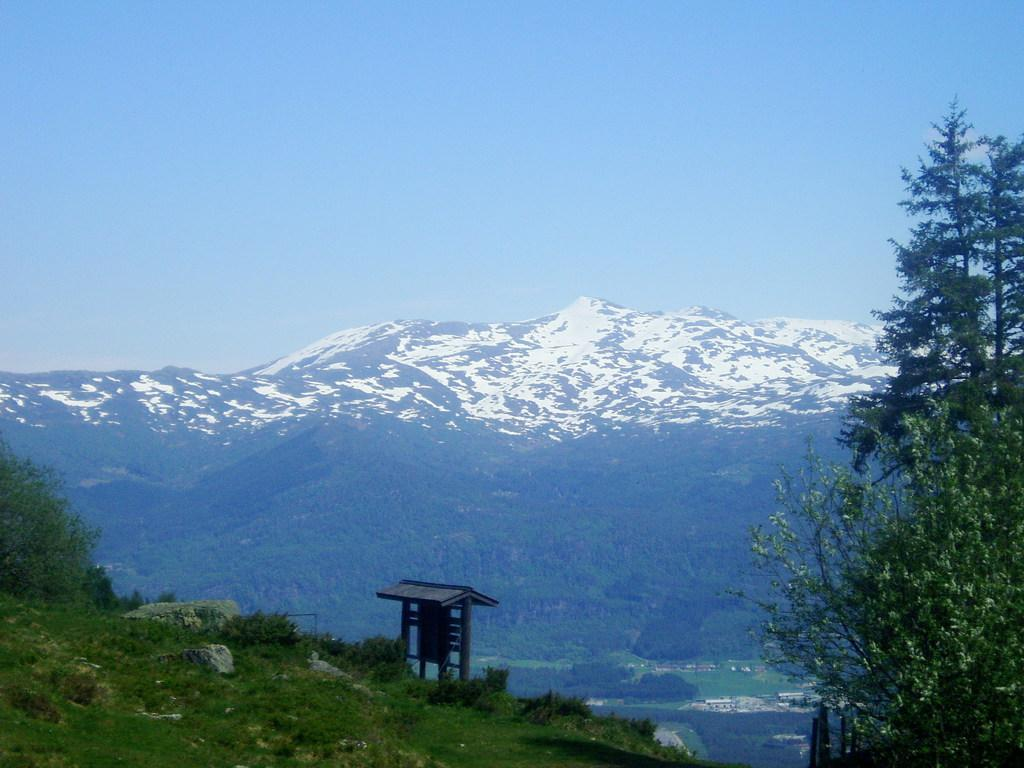What type of vegetation is on the right side of the image? There are trees on the right side of the image. What is present on the left side of the image? There are plants and rocks on the left side of the image, as well as a wooden object. What can be seen in the background of the image? Hills and the sky are visible in the background of the image. What is the condition of the hills in the image? The hills have snow on them. Can you tell me how many cars are parked near the wooden object in the image? There are no cars present in the image; it features trees, plants, rocks, a wooden object, hills, and the sky. What type of pet is visible in the image? There is no pet present in the image. 